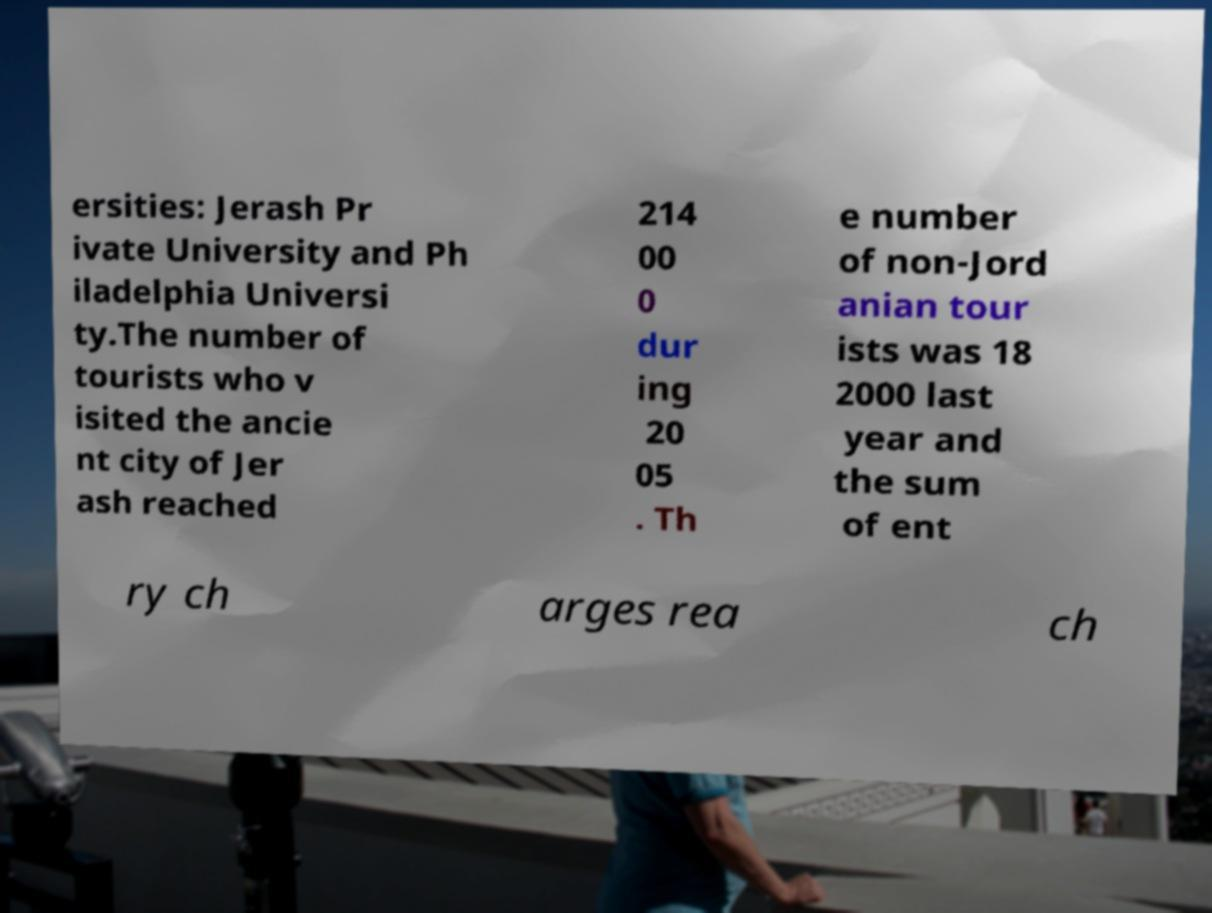For documentation purposes, I need the text within this image transcribed. Could you provide that? ersities: Jerash Pr ivate University and Ph iladelphia Universi ty.The number of tourists who v isited the ancie nt city of Jer ash reached 214 00 0 dur ing 20 05 . Th e number of non-Jord anian tour ists was 18 2000 last year and the sum of ent ry ch arges rea ch 